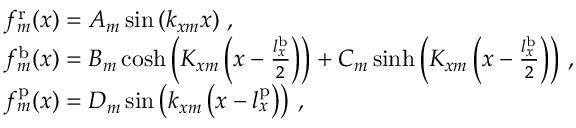Convert formula to latex. <formula><loc_0><loc_0><loc_500><loc_500>\begin{array} { r l } & { f _ { m } ^ { r } ( x ) = A _ { m } \sin \left ( k _ { x m } x \right ) \, , } \\ & { f _ { m } ^ { b } ( x ) = B _ { m } \cosh \left ( K _ { x m } \left ( x - \frac { l _ { x } ^ { b } } { 2 } \right ) \right ) + C _ { m } \sinh \left ( K _ { x m } \left ( x - \frac { l _ { x } ^ { b } } { 2 } \right ) \right ) \, , } \\ & { f _ { m } ^ { p } ( x ) = D _ { m } \sin \left ( k _ { x m } \left ( x - l _ { x } ^ { p } \right ) \right ) \, , } \end{array}</formula> 